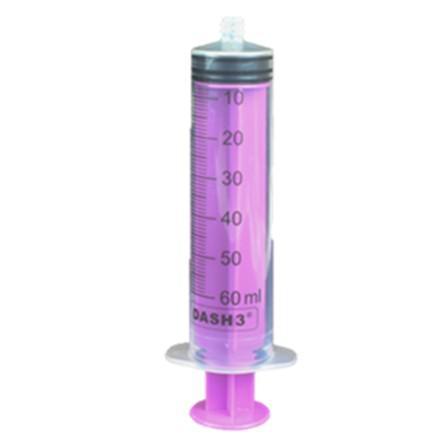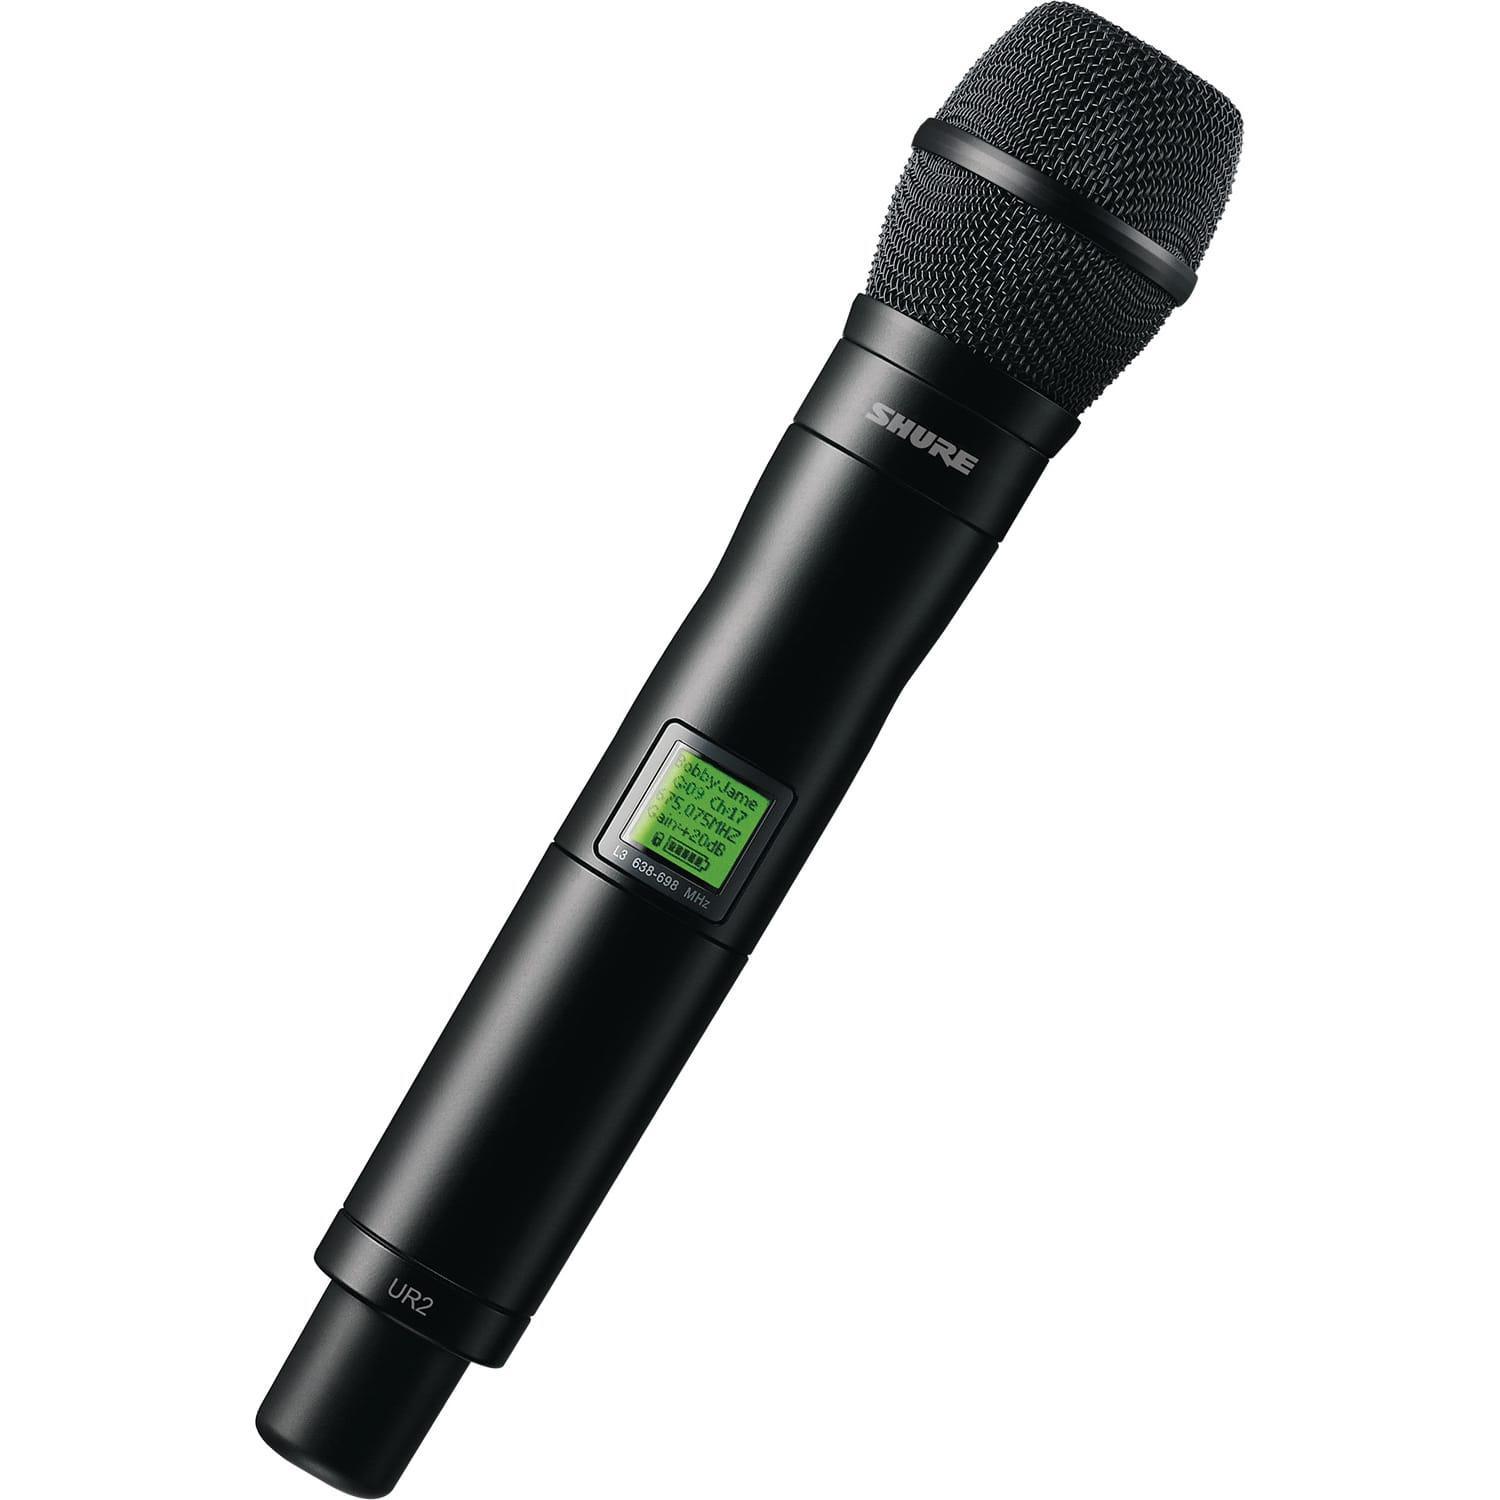The first image is the image on the left, the second image is the image on the right. Analyze the images presented: Is the assertion "There is one purple syringe and one metal tool all sideways with the right side up." valid? Answer yes or no. No. The first image is the image on the left, the second image is the image on the right. Assess this claim about the two images: "The syringe is marked to contain up to 60ml.". Correct or not? Answer yes or no. Yes. 